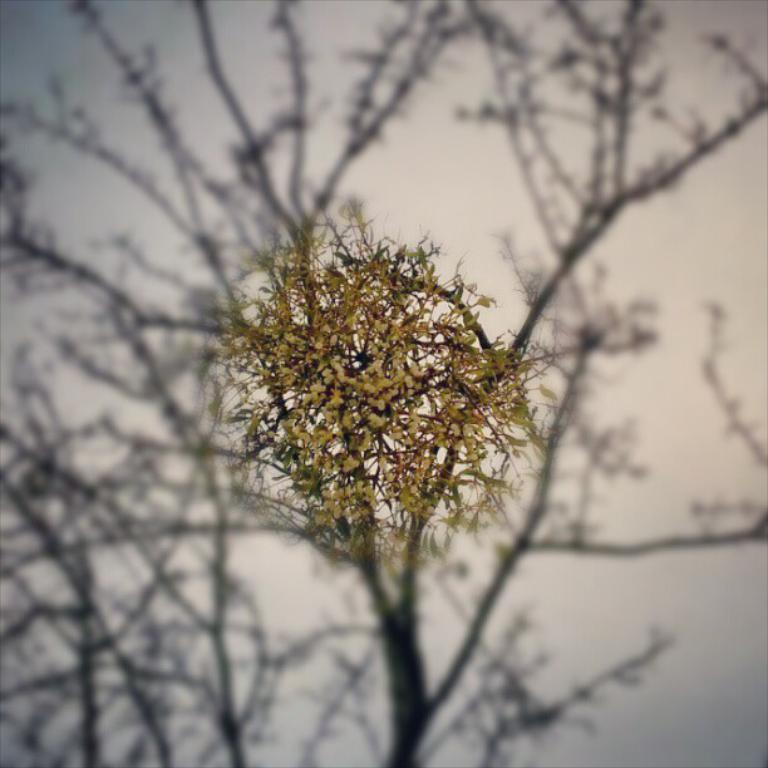In one or two sentences, can you explain what this image depicts? In this image this is some kind of flower and back side is totally blur. 